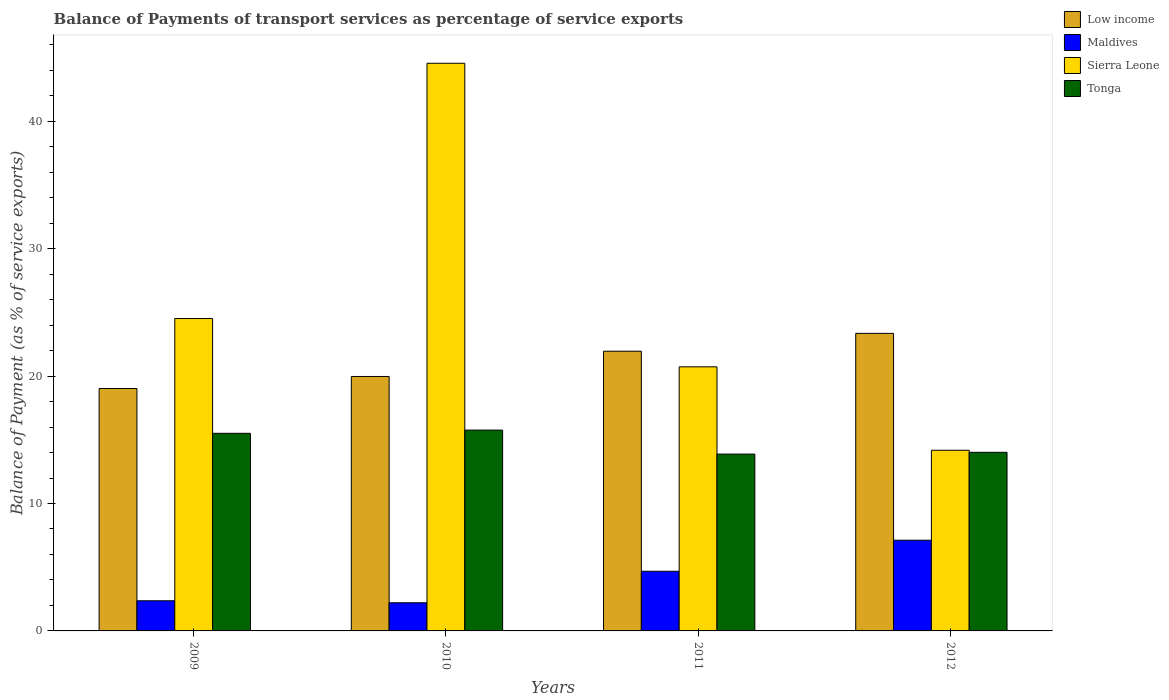How many groups of bars are there?
Offer a terse response. 4. Are the number of bars on each tick of the X-axis equal?
Your response must be concise. Yes. How many bars are there on the 2nd tick from the left?
Provide a succinct answer. 4. What is the label of the 2nd group of bars from the left?
Give a very brief answer. 2010. What is the balance of payments of transport services in Maldives in 2012?
Give a very brief answer. 7.12. Across all years, what is the maximum balance of payments of transport services in Tonga?
Provide a succinct answer. 15.76. Across all years, what is the minimum balance of payments of transport services in Sierra Leone?
Offer a very short reply. 14.18. In which year was the balance of payments of transport services in Sierra Leone maximum?
Give a very brief answer. 2010. In which year was the balance of payments of transport services in Maldives minimum?
Your answer should be compact. 2010. What is the total balance of payments of transport services in Tonga in the graph?
Keep it short and to the point. 59.17. What is the difference between the balance of payments of transport services in Low income in 2010 and that in 2012?
Give a very brief answer. -3.38. What is the difference between the balance of payments of transport services in Tonga in 2011 and the balance of payments of transport services in Sierra Leone in 2012?
Offer a terse response. -0.3. What is the average balance of payments of transport services in Low income per year?
Make the answer very short. 21.08. In the year 2012, what is the difference between the balance of payments of transport services in Low income and balance of payments of transport services in Tonga?
Keep it short and to the point. 9.34. What is the ratio of the balance of payments of transport services in Maldives in 2009 to that in 2011?
Your answer should be very brief. 0.51. Is the difference between the balance of payments of transport services in Low income in 2010 and 2011 greater than the difference between the balance of payments of transport services in Tonga in 2010 and 2011?
Your answer should be compact. No. What is the difference between the highest and the second highest balance of payments of transport services in Maldives?
Your response must be concise. 2.44. What is the difference between the highest and the lowest balance of payments of transport services in Tonga?
Your answer should be compact. 1.88. In how many years, is the balance of payments of transport services in Low income greater than the average balance of payments of transport services in Low income taken over all years?
Provide a succinct answer. 2. Is it the case that in every year, the sum of the balance of payments of transport services in Sierra Leone and balance of payments of transport services in Tonga is greater than the sum of balance of payments of transport services in Maldives and balance of payments of transport services in Low income?
Keep it short and to the point. No. What does the 2nd bar from the right in 2012 represents?
Provide a succinct answer. Sierra Leone. Is it the case that in every year, the sum of the balance of payments of transport services in Low income and balance of payments of transport services in Sierra Leone is greater than the balance of payments of transport services in Maldives?
Ensure brevity in your answer.  Yes. How many bars are there?
Your answer should be compact. 16. How many years are there in the graph?
Ensure brevity in your answer.  4. What is the difference between two consecutive major ticks on the Y-axis?
Provide a short and direct response. 10. Where does the legend appear in the graph?
Provide a succinct answer. Top right. How are the legend labels stacked?
Make the answer very short. Vertical. What is the title of the graph?
Provide a succinct answer. Balance of Payments of transport services as percentage of service exports. Does "Philippines" appear as one of the legend labels in the graph?
Your response must be concise. No. What is the label or title of the Y-axis?
Your answer should be compact. Balance of Payment (as % of service exports). What is the Balance of Payment (as % of service exports) of Low income in 2009?
Your answer should be very brief. 19.03. What is the Balance of Payment (as % of service exports) of Maldives in 2009?
Your answer should be very brief. 2.37. What is the Balance of Payment (as % of service exports) in Sierra Leone in 2009?
Your answer should be compact. 24.52. What is the Balance of Payment (as % of service exports) in Tonga in 2009?
Your response must be concise. 15.51. What is the Balance of Payment (as % of service exports) in Low income in 2010?
Provide a short and direct response. 19.97. What is the Balance of Payment (as % of service exports) in Maldives in 2010?
Offer a very short reply. 2.21. What is the Balance of Payment (as % of service exports) of Sierra Leone in 2010?
Your response must be concise. 44.56. What is the Balance of Payment (as % of service exports) in Tonga in 2010?
Offer a very short reply. 15.76. What is the Balance of Payment (as % of service exports) of Low income in 2011?
Ensure brevity in your answer.  21.95. What is the Balance of Payment (as % of service exports) in Maldives in 2011?
Ensure brevity in your answer.  4.68. What is the Balance of Payment (as % of service exports) of Sierra Leone in 2011?
Make the answer very short. 20.73. What is the Balance of Payment (as % of service exports) in Tonga in 2011?
Ensure brevity in your answer.  13.88. What is the Balance of Payment (as % of service exports) in Low income in 2012?
Offer a very short reply. 23.35. What is the Balance of Payment (as % of service exports) in Maldives in 2012?
Your response must be concise. 7.12. What is the Balance of Payment (as % of service exports) of Sierra Leone in 2012?
Keep it short and to the point. 14.18. What is the Balance of Payment (as % of service exports) in Tonga in 2012?
Provide a short and direct response. 14.02. Across all years, what is the maximum Balance of Payment (as % of service exports) of Low income?
Offer a very short reply. 23.35. Across all years, what is the maximum Balance of Payment (as % of service exports) of Maldives?
Offer a terse response. 7.12. Across all years, what is the maximum Balance of Payment (as % of service exports) in Sierra Leone?
Offer a very short reply. 44.56. Across all years, what is the maximum Balance of Payment (as % of service exports) of Tonga?
Your response must be concise. 15.76. Across all years, what is the minimum Balance of Payment (as % of service exports) in Low income?
Make the answer very short. 19.03. Across all years, what is the minimum Balance of Payment (as % of service exports) of Maldives?
Your answer should be compact. 2.21. Across all years, what is the minimum Balance of Payment (as % of service exports) in Sierra Leone?
Provide a succinct answer. 14.18. Across all years, what is the minimum Balance of Payment (as % of service exports) in Tonga?
Ensure brevity in your answer.  13.88. What is the total Balance of Payment (as % of service exports) of Low income in the graph?
Ensure brevity in your answer.  84.31. What is the total Balance of Payment (as % of service exports) in Maldives in the graph?
Your answer should be very brief. 16.38. What is the total Balance of Payment (as % of service exports) in Sierra Leone in the graph?
Give a very brief answer. 103.98. What is the total Balance of Payment (as % of service exports) of Tonga in the graph?
Give a very brief answer. 59.17. What is the difference between the Balance of Payment (as % of service exports) of Low income in 2009 and that in 2010?
Your response must be concise. -0.94. What is the difference between the Balance of Payment (as % of service exports) in Maldives in 2009 and that in 2010?
Provide a short and direct response. 0.16. What is the difference between the Balance of Payment (as % of service exports) of Sierra Leone in 2009 and that in 2010?
Provide a succinct answer. -20.04. What is the difference between the Balance of Payment (as % of service exports) of Tonga in 2009 and that in 2010?
Offer a very short reply. -0.25. What is the difference between the Balance of Payment (as % of service exports) of Low income in 2009 and that in 2011?
Your response must be concise. -2.93. What is the difference between the Balance of Payment (as % of service exports) in Maldives in 2009 and that in 2011?
Give a very brief answer. -2.32. What is the difference between the Balance of Payment (as % of service exports) in Sierra Leone in 2009 and that in 2011?
Your response must be concise. 3.79. What is the difference between the Balance of Payment (as % of service exports) of Tonga in 2009 and that in 2011?
Offer a very short reply. 1.63. What is the difference between the Balance of Payment (as % of service exports) in Low income in 2009 and that in 2012?
Ensure brevity in your answer.  -4.33. What is the difference between the Balance of Payment (as % of service exports) of Maldives in 2009 and that in 2012?
Your answer should be very brief. -4.75. What is the difference between the Balance of Payment (as % of service exports) in Sierra Leone in 2009 and that in 2012?
Keep it short and to the point. 10.34. What is the difference between the Balance of Payment (as % of service exports) of Tonga in 2009 and that in 2012?
Ensure brevity in your answer.  1.49. What is the difference between the Balance of Payment (as % of service exports) of Low income in 2010 and that in 2011?
Offer a terse response. -1.98. What is the difference between the Balance of Payment (as % of service exports) in Maldives in 2010 and that in 2011?
Offer a very short reply. -2.47. What is the difference between the Balance of Payment (as % of service exports) of Sierra Leone in 2010 and that in 2011?
Make the answer very short. 23.83. What is the difference between the Balance of Payment (as % of service exports) of Tonga in 2010 and that in 2011?
Your response must be concise. 1.88. What is the difference between the Balance of Payment (as % of service exports) of Low income in 2010 and that in 2012?
Provide a short and direct response. -3.38. What is the difference between the Balance of Payment (as % of service exports) of Maldives in 2010 and that in 2012?
Offer a terse response. -4.91. What is the difference between the Balance of Payment (as % of service exports) in Sierra Leone in 2010 and that in 2012?
Make the answer very short. 30.38. What is the difference between the Balance of Payment (as % of service exports) in Tonga in 2010 and that in 2012?
Offer a terse response. 1.74. What is the difference between the Balance of Payment (as % of service exports) in Low income in 2011 and that in 2012?
Your answer should be compact. -1.4. What is the difference between the Balance of Payment (as % of service exports) of Maldives in 2011 and that in 2012?
Give a very brief answer. -2.44. What is the difference between the Balance of Payment (as % of service exports) of Sierra Leone in 2011 and that in 2012?
Offer a terse response. 6.55. What is the difference between the Balance of Payment (as % of service exports) of Tonga in 2011 and that in 2012?
Your answer should be compact. -0.14. What is the difference between the Balance of Payment (as % of service exports) in Low income in 2009 and the Balance of Payment (as % of service exports) in Maldives in 2010?
Your answer should be compact. 16.82. What is the difference between the Balance of Payment (as % of service exports) of Low income in 2009 and the Balance of Payment (as % of service exports) of Sierra Leone in 2010?
Offer a very short reply. -25.53. What is the difference between the Balance of Payment (as % of service exports) in Low income in 2009 and the Balance of Payment (as % of service exports) in Tonga in 2010?
Keep it short and to the point. 3.27. What is the difference between the Balance of Payment (as % of service exports) in Maldives in 2009 and the Balance of Payment (as % of service exports) in Sierra Leone in 2010?
Provide a succinct answer. -42.19. What is the difference between the Balance of Payment (as % of service exports) of Maldives in 2009 and the Balance of Payment (as % of service exports) of Tonga in 2010?
Offer a very short reply. -13.39. What is the difference between the Balance of Payment (as % of service exports) in Sierra Leone in 2009 and the Balance of Payment (as % of service exports) in Tonga in 2010?
Your response must be concise. 8.76. What is the difference between the Balance of Payment (as % of service exports) of Low income in 2009 and the Balance of Payment (as % of service exports) of Maldives in 2011?
Offer a very short reply. 14.34. What is the difference between the Balance of Payment (as % of service exports) in Low income in 2009 and the Balance of Payment (as % of service exports) in Sierra Leone in 2011?
Your answer should be very brief. -1.7. What is the difference between the Balance of Payment (as % of service exports) of Low income in 2009 and the Balance of Payment (as % of service exports) of Tonga in 2011?
Make the answer very short. 5.15. What is the difference between the Balance of Payment (as % of service exports) in Maldives in 2009 and the Balance of Payment (as % of service exports) in Sierra Leone in 2011?
Give a very brief answer. -18.36. What is the difference between the Balance of Payment (as % of service exports) in Maldives in 2009 and the Balance of Payment (as % of service exports) in Tonga in 2011?
Make the answer very short. -11.51. What is the difference between the Balance of Payment (as % of service exports) of Sierra Leone in 2009 and the Balance of Payment (as % of service exports) of Tonga in 2011?
Offer a very short reply. 10.64. What is the difference between the Balance of Payment (as % of service exports) in Low income in 2009 and the Balance of Payment (as % of service exports) in Maldives in 2012?
Offer a terse response. 11.91. What is the difference between the Balance of Payment (as % of service exports) in Low income in 2009 and the Balance of Payment (as % of service exports) in Sierra Leone in 2012?
Ensure brevity in your answer.  4.85. What is the difference between the Balance of Payment (as % of service exports) in Low income in 2009 and the Balance of Payment (as % of service exports) in Tonga in 2012?
Provide a succinct answer. 5.01. What is the difference between the Balance of Payment (as % of service exports) in Maldives in 2009 and the Balance of Payment (as % of service exports) in Sierra Leone in 2012?
Offer a very short reply. -11.81. What is the difference between the Balance of Payment (as % of service exports) of Maldives in 2009 and the Balance of Payment (as % of service exports) of Tonga in 2012?
Make the answer very short. -11.65. What is the difference between the Balance of Payment (as % of service exports) in Sierra Leone in 2009 and the Balance of Payment (as % of service exports) in Tonga in 2012?
Make the answer very short. 10.5. What is the difference between the Balance of Payment (as % of service exports) of Low income in 2010 and the Balance of Payment (as % of service exports) of Maldives in 2011?
Your response must be concise. 15.29. What is the difference between the Balance of Payment (as % of service exports) of Low income in 2010 and the Balance of Payment (as % of service exports) of Sierra Leone in 2011?
Offer a very short reply. -0.76. What is the difference between the Balance of Payment (as % of service exports) of Low income in 2010 and the Balance of Payment (as % of service exports) of Tonga in 2011?
Your answer should be compact. 6.09. What is the difference between the Balance of Payment (as % of service exports) of Maldives in 2010 and the Balance of Payment (as % of service exports) of Sierra Leone in 2011?
Your answer should be very brief. -18.52. What is the difference between the Balance of Payment (as % of service exports) of Maldives in 2010 and the Balance of Payment (as % of service exports) of Tonga in 2011?
Give a very brief answer. -11.67. What is the difference between the Balance of Payment (as % of service exports) in Sierra Leone in 2010 and the Balance of Payment (as % of service exports) in Tonga in 2011?
Offer a very short reply. 30.68. What is the difference between the Balance of Payment (as % of service exports) of Low income in 2010 and the Balance of Payment (as % of service exports) of Maldives in 2012?
Your answer should be very brief. 12.85. What is the difference between the Balance of Payment (as % of service exports) of Low income in 2010 and the Balance of Payment (as % of service exports) of Sierra Leone in 2012?
Ensure brevity in your answer.  5.79. What is the difference between the Balance of Payment (as % of service exports) of Low income in 2010 and the Balance of Payment (as % of service exports) of Tonga in 2012?
Give a very brief answer. 5.95. What is the difference between the Balance of Payment (as % of service exports) in Maldives in 2010 and the Balance of Payment (as % of service exports) in Sierra Leone in 2012?
Offer a very short reply. -11.97. What is the difference between the Balance of Payment (as % of service exports) in Maldives in 2010 and the Balance of Payment (as % of service exports) in Tonga in 2012?
Give a very brief answer. -11.81. What is the difference between the Balance of Payment (as % of service exports) in Sierra Leone in 2010 and the Balance of Payment (as % of service exports) in Tonga in 2012?
Your answer should be compact. 30.54. What is the difference between the Balance of Payment (as % of service exports) in Low income in 2011 and the Balance of Payment (as % of service exports) in Maldives in 2012?
Offer a very short reply. 14.83. What is the difference between the Balance of Payment (as % of service exports) of Low income in 2011 and the Balance of Payment (as % of service exports) of Sierra Leone in 2012?
Your answer should be compact. 7.77. What is the difference between the Balance of Payment (as % of service exports) of Low income in 2011 and the Balance of Payment (as % of service exports) of Tonga in 2012?
Offer a very short reply. 7.94. What is the difference between the Balance of Payment (as % of service exports) of Maldives in 2011 and the Balance of Payment (as % of service exports) of Sierra Leone in 2012?
Offer a terse response. -9.5. What is the difference between the Balance of Payment (as % of service exports) in Maldives in 2011 and the Balance of Payment (as % of service exports) in Tonga in 2012?
Provide a short and direct response. -9.34. What is the difference between the Balance of Payment (as % of service exports) of Sierra Leone in 2011 and the Balance of Payment (as % of service exports) of Tonga in 2012?
Ensure brevity in your answer.  6.71. What is the average Balance of Payment (as % of service exports) in Low income per year?
Offer a very short reply. 21.08. What is the average Balance of Payment (as % of service exports) of Maldives per year?
Offer a very short reply. 4.1. What is the average Balance of Payment (as % of service exports) of Sierra Leone per year?
Your response must be concise. 26. What is the average Balance of Payment (as % of service exports) in Tonga per year?
Provide a succinct answer. 14.79. In the year 2009, what is the difference between the Balance of Payment (as % of service exports) in Low income and Balance of Payment (as % of service exports) in Maldives?
Your answer should be very brief. 16.66. In the year 2009, what is the difference between the Balance of Payment (as % of service exports) in Low income and Balance of Payment (as % of service exports) in Sierra Leone?
Make the answer very short. -5.49. In the year 2009, what is the difference between the Balance of Payment (as % of service exports) of Low income and Balance of Payment (as % of service exports) of Tonga?
Provide a short and direct response. 3.52. In the year 2009, what is the difference between the Balance of Payment (as % of service exports) in Maldives and Balance of Payment (as % of service exports) in Sierra Leone?
Offer a very short reply. -22.15. In the year 2009, what is the difference between the Balance of Payment (as % of service exports) of Maldives and Balance of Payment (as % of service exports) of Tonga?
Provide a short and direct response. -13.14. In the year 2009, what is the difference between the Balance of Payment (as % of service exports) in Sierra Leone and Balance of Payment (as % of service exports) in Tonga?
Your answer should be compact. 9.01. In the year 2010, what is the difference between the Balance of Payment (as % of service exports) of Low income and Balance of Payment (as % of service exports) of Maldives?
Your answer should be very brief. 17.76. In the year 2010, what is the difference between the Balance of Payment (as % of service exports) in Low income and Balance of Payment (as % of service exports) in Sierra Leone?
Your response must be concise. -24.58. In the year 2010, what is the difference between the Balance of Payment (as % of service exports) in Low income and Balance of Payment (as % of service exports) in Tonga?
Provide a short and direct response. 4.21. In the year 2010, what is the difference between the Balance of Payment (as % of service exports) of Maldives and Balance of Payment (as % of service exports) of Sierra Leone?
Offer a very short reply. -42.34. In the year 2010, what is the difference between the Balance of Payment (as % of service exports) of Maldives and Balance of Payment (as % of service exports) of Tonga?
Your answer should be compact. -13.55. In the year 2010, what is the difference between the Balance of Payment (as % of service exports) in Sierra Leone and Balance of Payment (as % of service exports) in Tonga?
Your answer should be compact. 28.79. In the year 2011, what is the difference between the Balance of Payment (as % of service exports) in Low income and Balance of Payment (as % of service exports) in Maldives?
Ensure brevity in your answer.  17.27. In the year 2011, what is the difference between the Balance of Payment (as % of service exports) in Low income and Balance of Payment (as % of service exports) in Sierra Leone?
Offer a terse response. 1.23. In the year 2011, what is the difference between the Balance of Payment (as % of service exports) in Low income and Balance of Payment (as % of service exports) in Tonga?
Provide a succinct answer. 8.07. In the year 2011, what is the difference between the Balance of Payment (as % of service exports) of Maldives and Balance of Payment (as % of service exports) of Sierra Leone?
Provide a succinct answer. -16.05. In the year 2011, what is the difference between the Balance of Payment (as % of service exports) in Maldives and Balance of Payment (as % of service exports) in Tonga?
Make the answer very short. -9.2. In the year 2011, what is the difference between the Balance of Payment (as % of service exports) in Sierra Leone and Balance of Payment (as % of service exports) in Tonga?
Ensure brevity in your answer.  6.85. In the year 2012, what is the difference between the Balance of Payment (as % of service exports) of Low income and Balance of Payment (as % of service exports) of Maldives?
Keep it short and to the point. 16.23. In the year 2012, what is the difference between the Balance of Payment (as % of service exports) of Low income and Balance of Payment (as % of service exports) of Sierra Leone?
Your answer should be very brief. 9.17. In the year 2012, what is the difference between the Balance of Payment (as % of service exports) of Low income and Balance of Payment (as % of service exports) of Tonga?
Offer a terse response. 9.34. In the year 2012, what is the difference between the Balance of Payment (as % of service exports) of Maldives and Balance of Payment (as % of service exports) of Sierra Leone?
Your response must be concise. -7.06. In the year 2012, what is the difference between the Balance of Payment (as % of service exports) in Maldives and Balance of Payment (as % of service exports) in Tonga?
Ensure brevity in your answer.  -6.9. In the year 2012, what is the difference between the Balance of Payment (as % of service exports) in Sierra Leone and Balance of Payment (as % of service exports) in Tonga?
Provide a succinct answer. 0.16. What is the ratio of the Balance of Payment (as % of service exports) of Low income in 2009 to that in 2010?
Give a very brief answer. 0.95. What is the ratio of the Balance of Payment (as % of service exports) in Maldives in 2009 to that in 2010?
Offer a very short reply. 1.07. What is the ratio of the Balance of Payment (as % of service exports) of Sierra Leone in 2009 to that in 2010?
Provide a short and direct response. 0.55. What is the ratio of the Balance of Payment (as % of service exports) in Low income in 2009 to that in 2011?
Provide a succinct answer. 0.87. What is the ratio of the Balance of Payment (as % of service exports) in Maldives in 2009 to that in 2011?
Your response must be concise. 0.51. What is the ratio of the Balance of Payment (as % of service exports) in Sierra Leone in 2009 to that in 2011?
Give a very brief answer. 1.18. What is the ratio of the Balance of Payment (as % of service exports) of Tonga in 2009 to that in 2011?
Your answer should be compact. 1.12. What is the ratio of the Balance of Payment (as % of service exports) in Low income in 2009 to that in 2012?
Provide a succinct answer. 0.81. What is the ratio of the Balance of Payment (as % of service exports) in Maldives in 2009 to that in 2012?
Provide a short and direct response. 0.33. What is the ratio of the Balance of Payment (as % of service exports) in Sierra Leone in 2009 to that in 2012?
Your response must be concise. 1.73. What is the ratio of the Balance of Payment (as % of service exports) of Tonga in 2009 to that in 2012?
Keep it short and to the point. 1.11. What is the ratio of the Balance of Payment (as % of service exports) in Low income in 2010 to that in 2011?
Keep it short and to the point. 0.91. What is the ratio of the Balance of Payment (as % of service exports) in Maldives in 2010 to that in 2011?
Offer a terse response. 0.47. What is the ratio of the Balance of Payment (as % of service exports) in Sierra Leone in 2010 to that in 2011?
Ensure brevity in your answer.  2.15. What is the ratio of the Balance of Payment (as % of service exports) in Tonga in 2010 to that in 2011?
Provide a short and direct response. 1.14. What is the ratio of the Balance of Payment (as % of service exports) in Low income in 2010 to that in 2012?
Ensure brevity in your answer.  0.86. What is the ratio of the Balance of Payment (as % of service exports) in Maldives in 2010 to that in 2012?
Provide a succinct answer. 0.31. What is the ratio of the Balance of Payment (as % of service exports) of Sierra Leone in 2010 to that in 2012?
Offer a very short reply. 3.14. What is the ratio of the Balance of Payment (as % of service exports) in Tonga in 2010 to that in 2012?
Offer a terse response. 1.12. What is the ratio of the Balance of Payment (as % of service exports) in Maldives in 2011 to that in 2012?
Give a very brief answer. 0.66. What is the ratio of the Balance of Payment (as % of service exports) in Sierra Leone in 2011 to that in 2012?
Your response must be concise. 1.46. What is the ratio of the Balance of Payment (as % of service exports) in Tonga in 2011 to that in 2012?
Make the answer very short. 0.99. What is the difference between the highest and the second highest Balance of Payment (as % of service exports) of Low income?
Provide a succinct answer. 1.4. What is the difference between the highest and the second highest Balance of Payment (as % of service exports) in Maldives?
Provide a short and direct response. 2.44. What is the difference between the highest and the second highest Balance of Payment (as % of service exports) of Sierra Leone?
Give a very brief answer. 20.04. What is the difference between the highest and the second highest Balance of Payment (as % of service exports) in Tonga?
Your answer should be compact. 0.25. What is the difference between the highest and the lowest Balance of Payment (as % of service exports) of Low income?
Provide a short and direct response. 4.33. What is the difference between the highest and the lowest Balance of Payment (as % of service exports) of Maldives?
Provide a short and direct response. 4.91. What is the difference between the highest and the lowest Balance of Payment (as % of service exports) in Sierra Leone?
Your answer should be compact. 30.38. What is the difference between the highest and the lowest Balance of Payment (as % of service exports) of Tonga?
Ensure brevity in your answer.  1.88. 